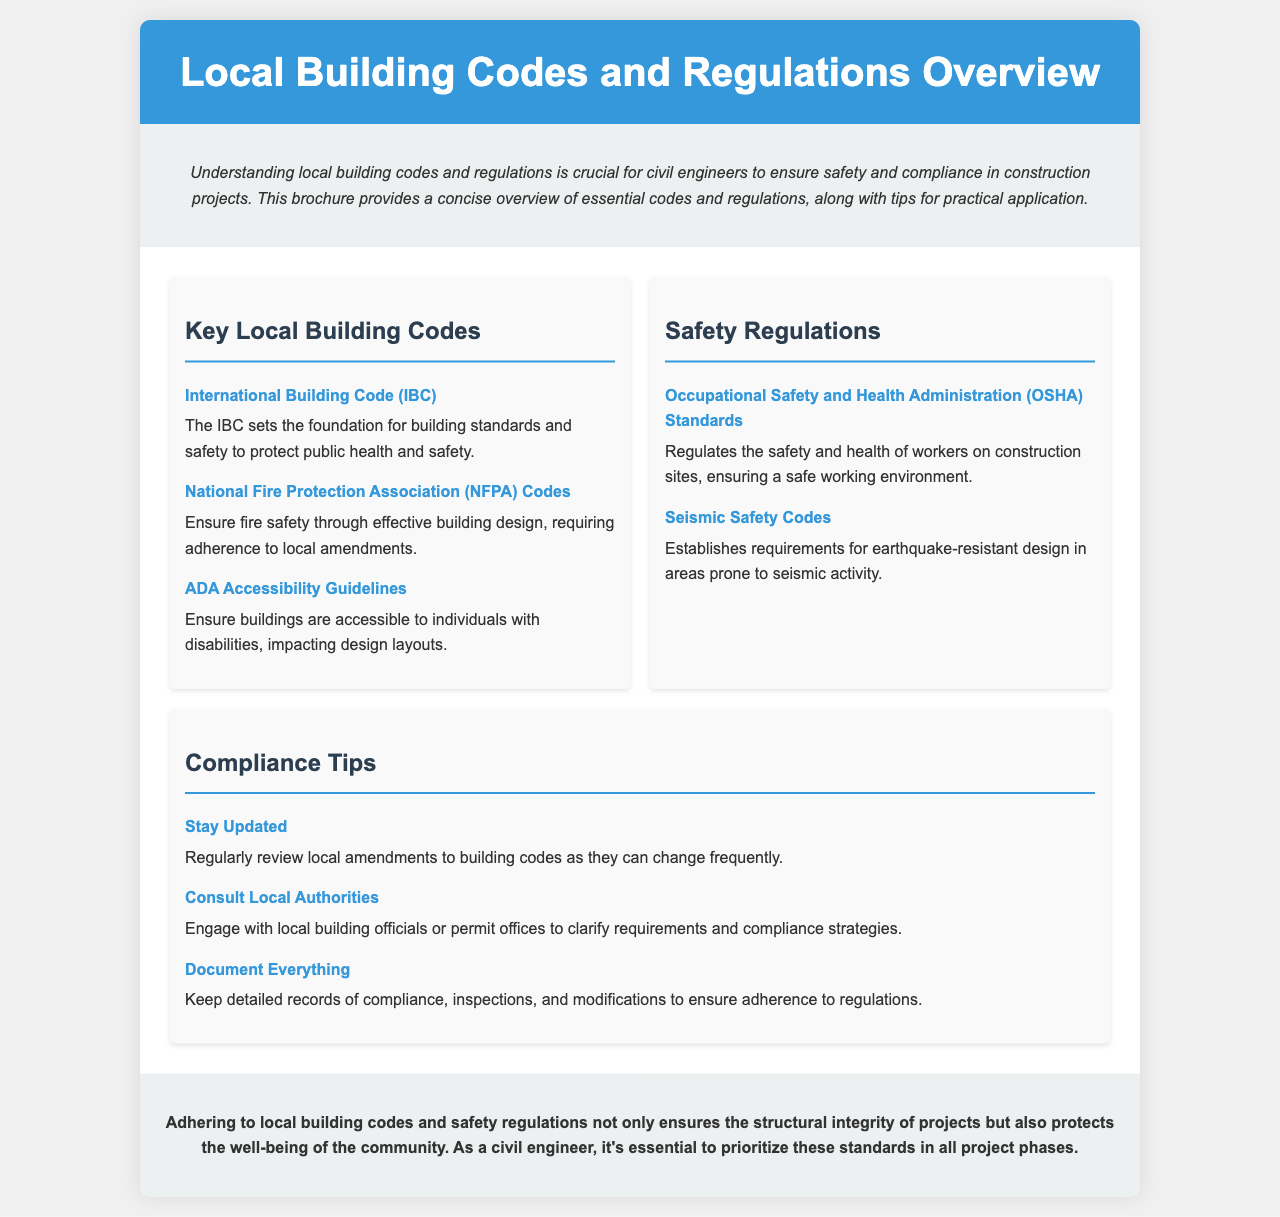What is the title of the brochure? The title is indicated at the top of the document and highlights what the brochure is about.
Answer: Local Building Codes and Regulations Overview What does IBC stand for? IBC is an abbreviation mentioned within the context of key local building codes.
Answer: International Building Code Which organization sets the fire safety codes? The document specifies the association responsible for fire safety regulations.
Answer: National Fire Protection Association What type of codes ensure accessibility for individuals with disabilities? The document mentions specific guidelines that focus on accessibility considerations.
Answer: ADA Accessibility Guidelines Which safety standards regulate construction site worker health? The document provides the title of the standards governing worker safety.
Answer: Occupational Safety and Health Administration What is a compliance tip regarding local amendments? The brochure gives practical advice related to keeping informed about building codes.
Answer: Stay Updated What should civil engineers keep to ensure adherence to regulations? The document emphasizes the importance of maintaining certain documentation.
Answer: Detailed records What types of safety requirements are established for seismic activity? The section on safety regulations discusses specific design requirements.
Answer: Seismic Safety Codes What is the main message conveyed in the conclusion? The conclusion summarizes the essential aspect of following regulations for project integrity and community safety.
Answer: Protects the well-being of the community 